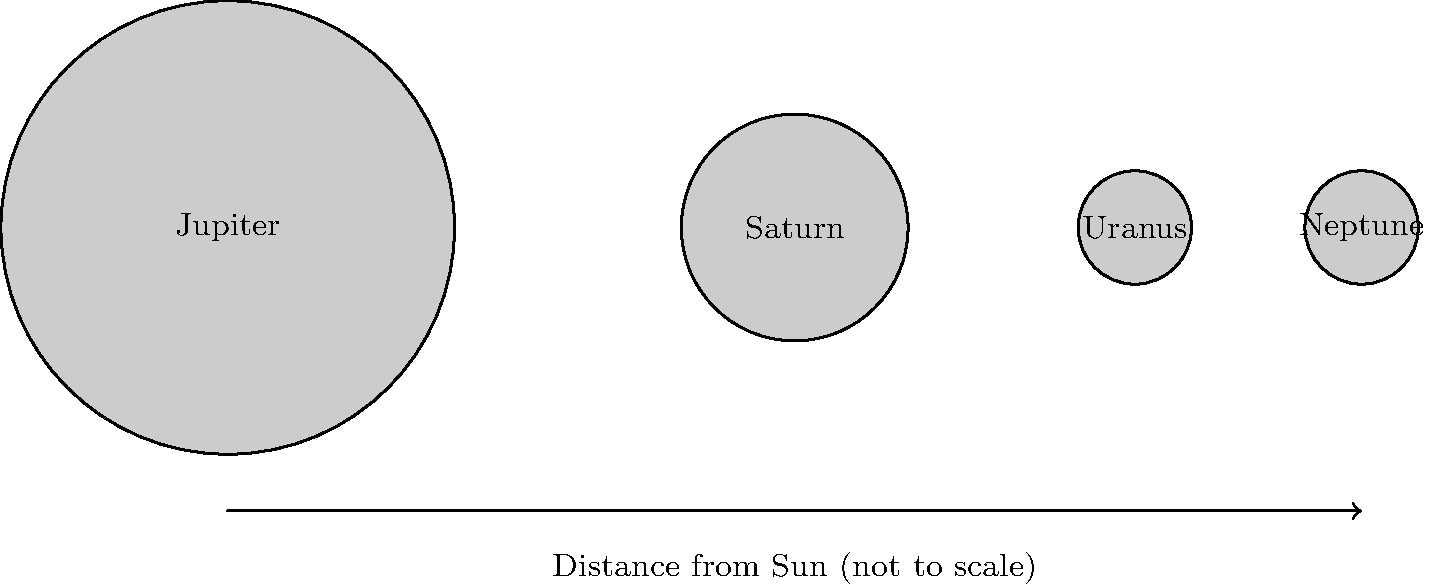As a psychotherapist who often uses analogies to explain complex concepts, how might you use the relative sizes and distances of the gas giants in our Solar System to illustrate the importance of perspective in mental health? Consider the diagram showing Jupiter, Saturn, Uranus, and Neptune (not to scale). To answer this question, let's break down the information from the diagram and relate it to mental health concepts:

1. Size differences:
   - Jupiter is the largest, followed by Saturn, then Uranus and Neptune (roughly equal).
   - This can represent how problems or emotions may appear larger or smaller depending on our perspective.

2. Distance from the Sun:
   - The planets are arranged in order of increasing distance from the Sun.
   - This can symbolize how distance (emotional or temporal) can affect our perception of issues.

3. Relative scale:
   - The diagram is not to scale, which is crucial for understanding the actual relationships between these planets.
   - This illustrates how our perception can be distorted and may not accurately reflect reality.

4. Perspective in mental health:
   - Just as the appearance of planets changes based on our viewpoint, mental health issues can seem different depending on our current state of mind.
   - Closer problems (like Jupiter) may seem overwhelmingly large, while distant ones (like Neptune) may appear smaller or less significant.

5. Therapeutic application:
   - Encourage clients to "step back" and view their problems from different perspectives, like an astronomer studying the solar system as a whole.
   - Help clients understand that the perceived size of a problem doesn't always correlate with its actual impact or importance.

6. Holistic view:
   - Just as understanding the solar system requires considering all planets, addressing mental health involves examining all aspects of a person's life.

7. Change over time:
   - As planets orbit, their relative positions change, similar to how our perspective on problems can shift with time and personal growth.

By using this astronomical analogy, a psychotherapist can help clients visualize the concept of perspective in mental health, encouraging a more balanced and holistic view of their challenges and experiences.
Answer: Planetary size and distance analogy illustrates how perspective influences perception of problems in mental health, emphasizing the importance of viewing issues from different viewpoints for a more balanced understanding. 